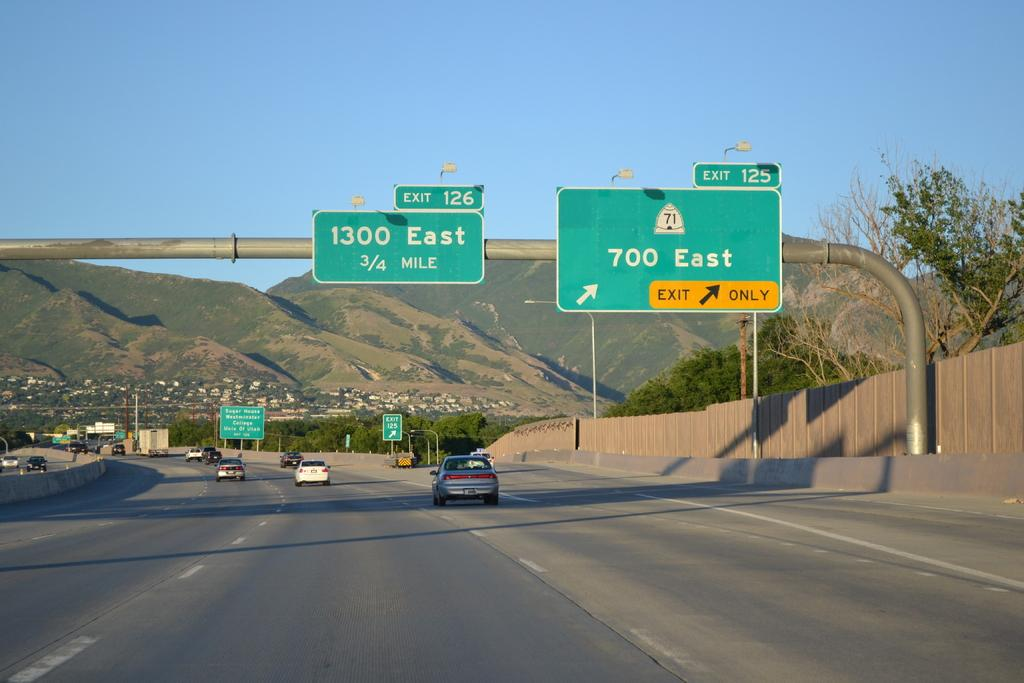<image>
Give a short and clear explanation of the subsequent image. Two large green and white highway signs for 1300 east and 700 east. 